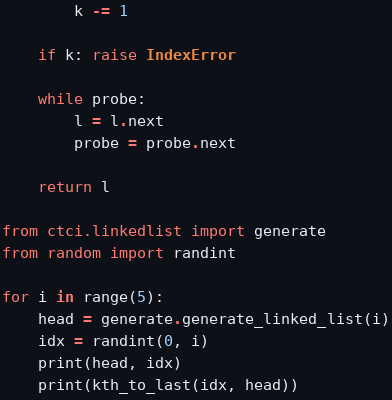<code> <loc_0><loc_0><loc_500><loc_500><_Python_>        k -= 1

    if k: raise IndexError

    while probe:
        l = l.next
        probe = probe.next

    return l

from ctci.linkedlist import generate
from random import randint

for i in range(5):
    head = generate.generate_linked_list(i)
    idx = randint(0, i)
    print(head, idx)
    print(kth_to_last(idx, head))</code> 